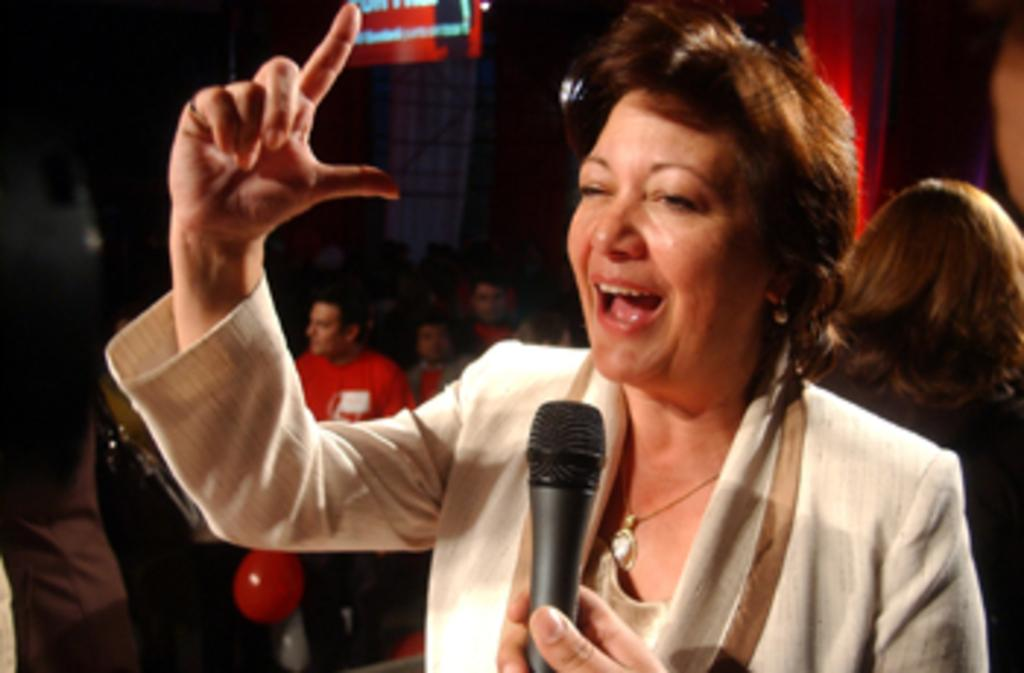Who is the main subject in the image? There is a woman in the image. What is the woman holding in the image? The woman is holding a mic. Can you describe the background of the image? There are people in the background of the image. What type of soap is the woman using to clean the seat in the image? There is no soap or seat present in the image. 